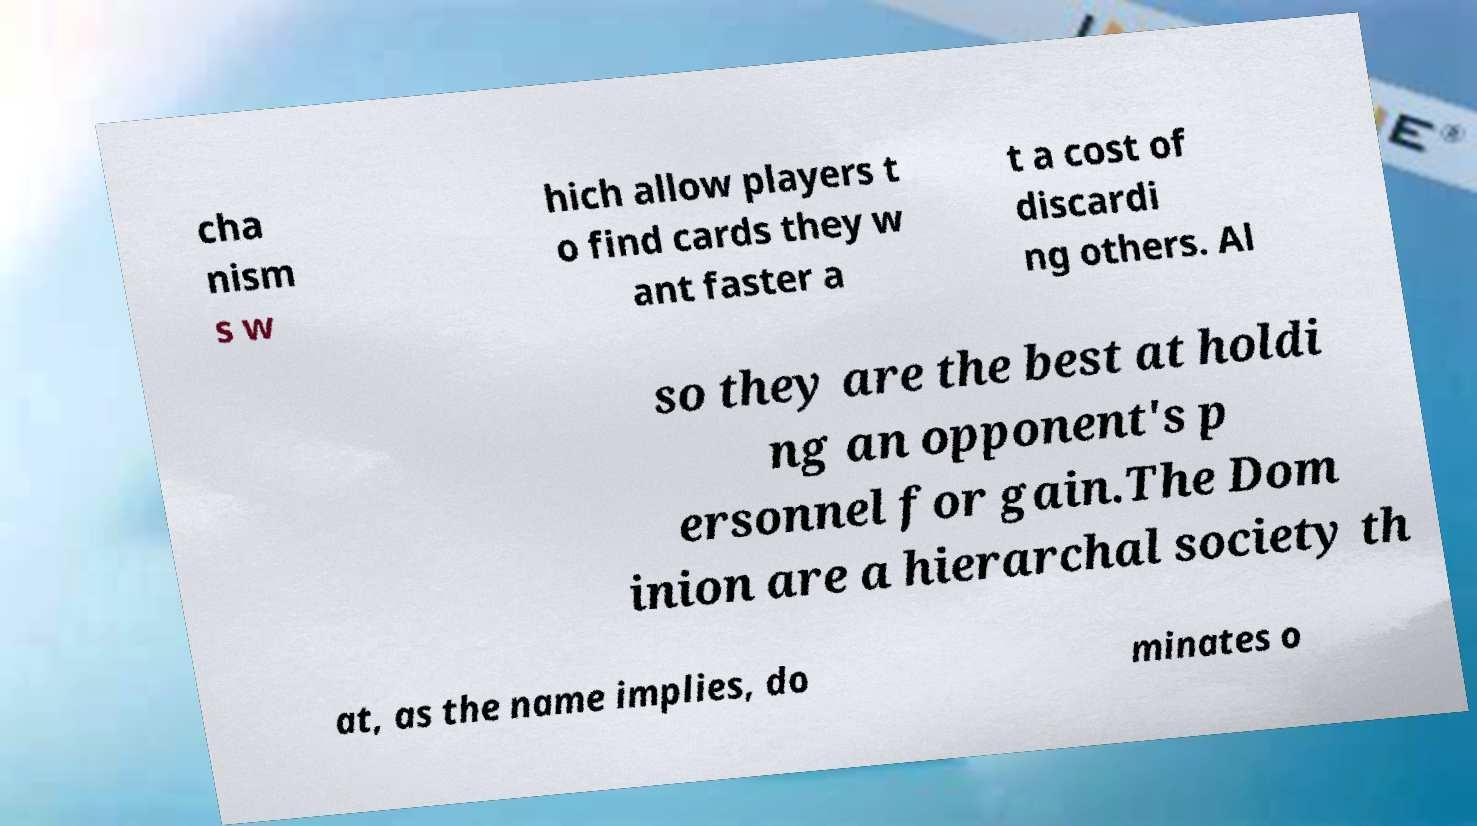Can you accurately transcribe the text from the provided image for me? cha nism s w hich allow players t o find cards they w ant faster a t a cost of discardi ng others. Al so they are the best at holdi ng an opponent's p ersonnel for gain.The Dom inion are a hierarchal society th at, as the name implies, do minates o 